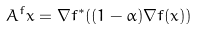<formula> <loc_0><loc_0><loc_500><loc_500>A ^ { f } x = \nabla f ^ { \ast } ( ( 1 - \alpha ) \nabla f ( x ) )</formula> 